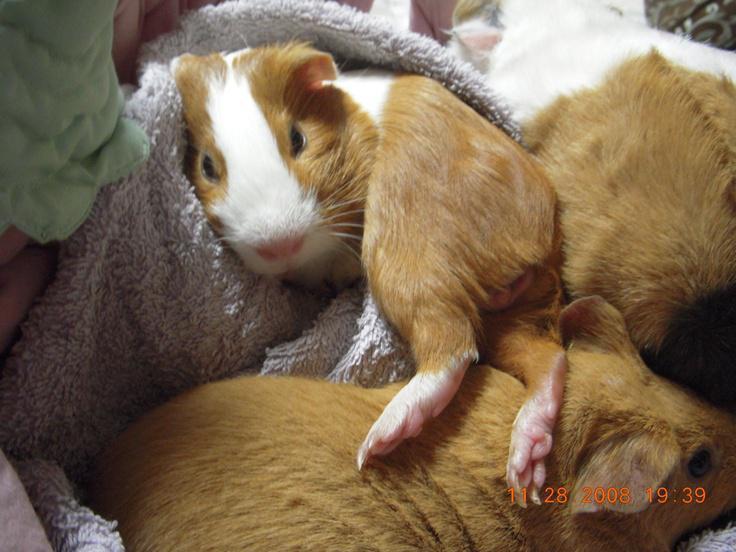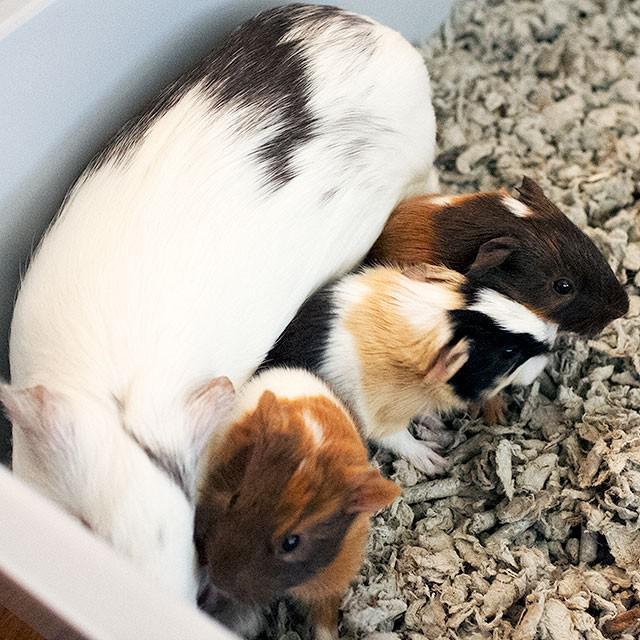The first image is the image on the left, the second image is the image on the right. Analyze the images presented: Is the assertion "One image shows a hamster laying with an animal that is not a hamster." valid? Answer yes or no. No. 